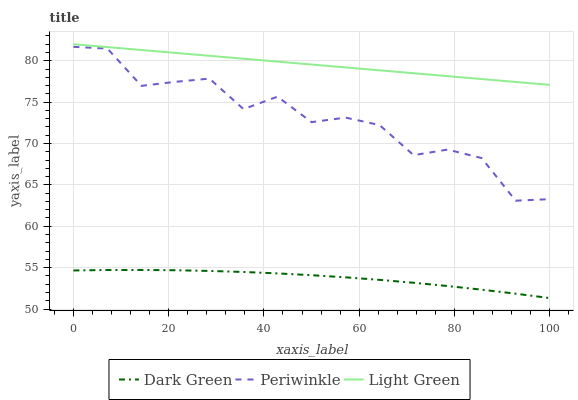Does Dark Green have the minimum area under the curve?
Answer yes or no. Yes. Does Light Green have the maximum area under the curve?
Answer yes or no. Yes. Does Light Green have the minimum area under the curve?
Answer yes or no. No. Does Dark Green have the maximum area under the curve?
Answer yes or no. No. Is Light Green the smoothest?
Answer yes or no. Yes. Is Periwinkle the roughest?
Answer yes or no. Yes. Is Dark Green the smoothest?
Answer yes or no. No. Is Dark Green the roughest?
Answer yes or no. No. Does Dark Green have the lowest value?
Answer yes or no. Yes. Does Light Green have the lowest value?
Answer yes or no. No. Does Light Green have the highest value?
Answer yes or no. Yes. Does Dark Green have the highest value?
Answer yes or no. No. Is Dark Green less than Periwinkle?
Answer yes or no. Yes. Is Light Green greater than Dark Green?
Answer yes or no. Yes. Does Dark Green intersect Periwinkle?
Answer yes or no. No. 